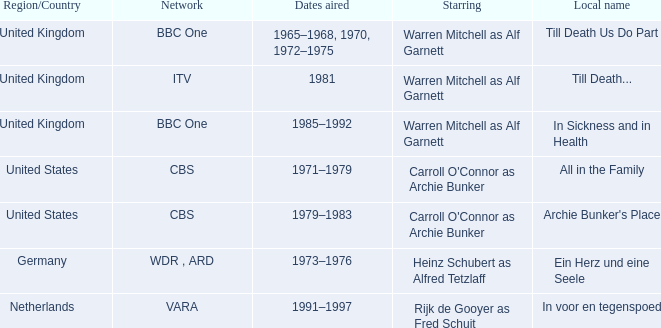What is the local name for the episodes that aired in 1981? Till Death... 